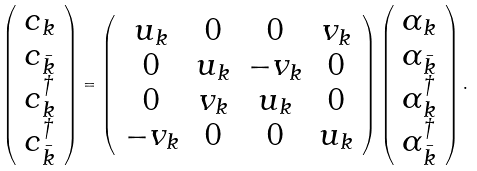Convert formula to latex. <formula><loc_0><loc_0><loc_500><loc_500>\left ( \begin{array} { c } c _ { k } \\ c _ { \bar { k } } \\ c _ { k } ^ { \dagger } \\ c _ { \bar { k } } ^ { \dagger } \end{array} \right ) = \left ( \begin{array} { c c c c } u _ { k } & 0 & 0 & v _ { k } \\ 0 & u _ { k } & - v _ { k } & 0 \\ 0 & v _ { k } & u _ { k } & 0 \\ - v _ { k } & 0 & 0 & u _ { k } \end{array} \right ) \left ( \begin{array} { c } \alpha _ { k } \\ \alpha _ { \bar { k } } \\ \alpha _ { k } ^ { \dagger } \\ \alpha _ { \bar { k } } ^ { \dagger } \end{array} \right ) .</formula> 